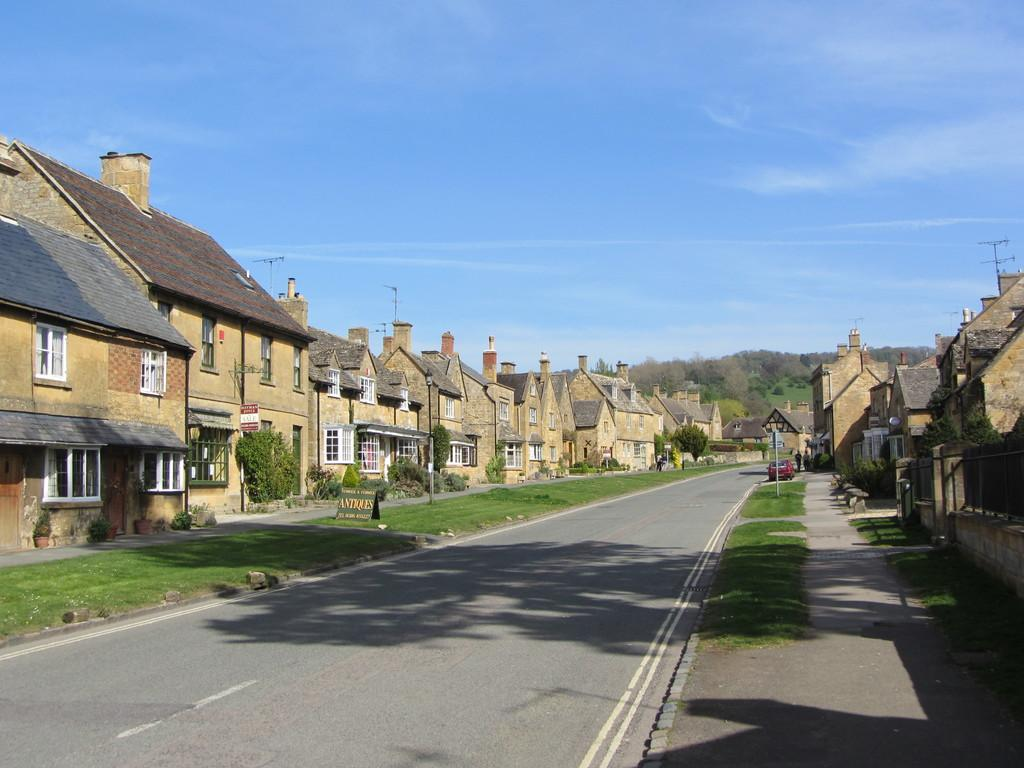What is the color of the sky in the image? The sky is blue in the image. What type of structures can be seen in the image? There are buildings in the image. What can be seen on the buildings in the image? Windows are visible in the image. What type of vegetation is present in the image? Grass and plants are visible in the image. What is on the road in the image? There is a vehicle on the road. What type of natural features can be seen far in the image? Trees are located far in the image. What is the opinion of the boys about the milk in the image? There are no boys or milk present in the image, so it is not possible to determine their opinion. 